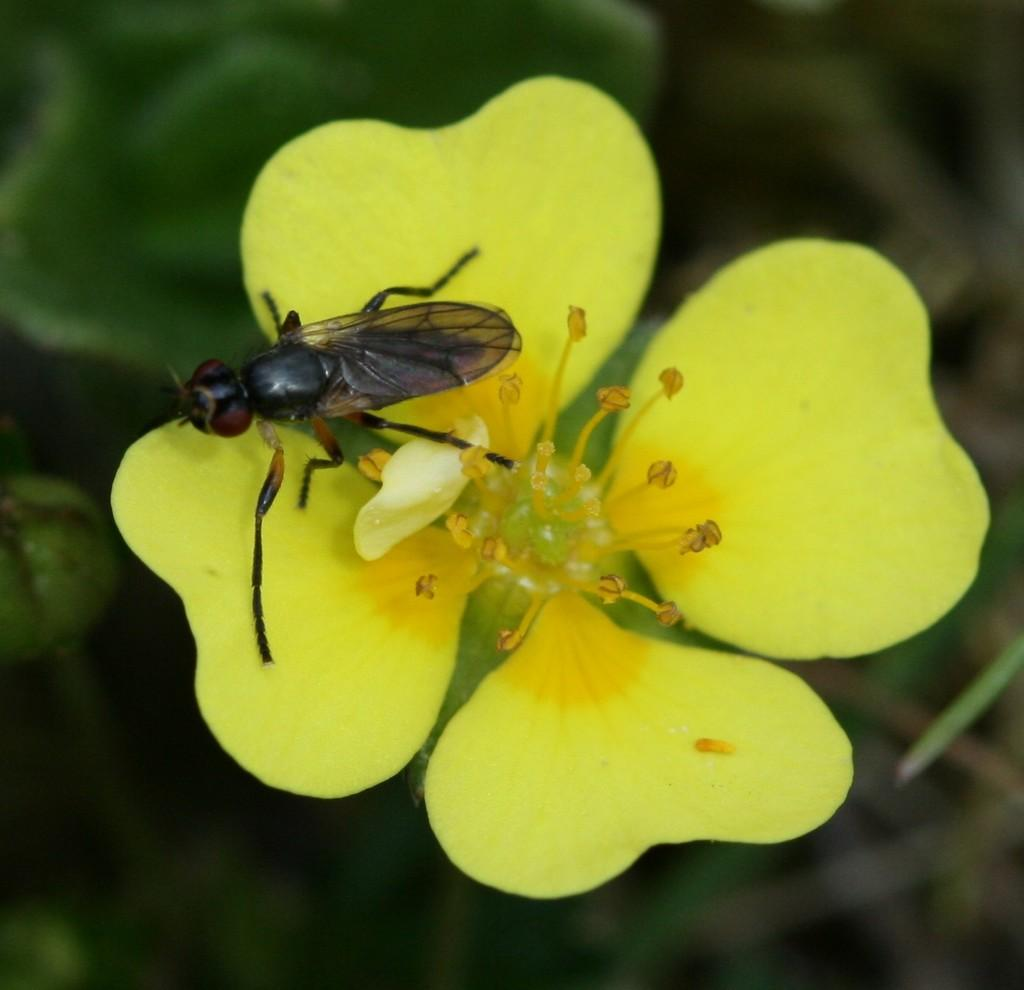What is present on the flower in the image? There is an insect on the flower in the image. Where is the flower located in the image? The flower is in the center of the image. What type of paste is being applied to the insect's tail in the image? There is no paste or tail present in the image; it features an insect on a flower. 